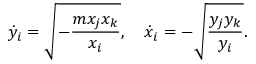Convert formula to latex. <formula><loc_0><loc_0><loc_500><loc_500>\dot { y } _ { i } = \sqrt { - { \frac { m x _ { j } x _ { k } } { x _ { i } } } } , \quad \dot { x } _ { i } = - \sqrt { { \frac { y _ { j } y _ { k } } { y _ { i } } } } .</formula> 